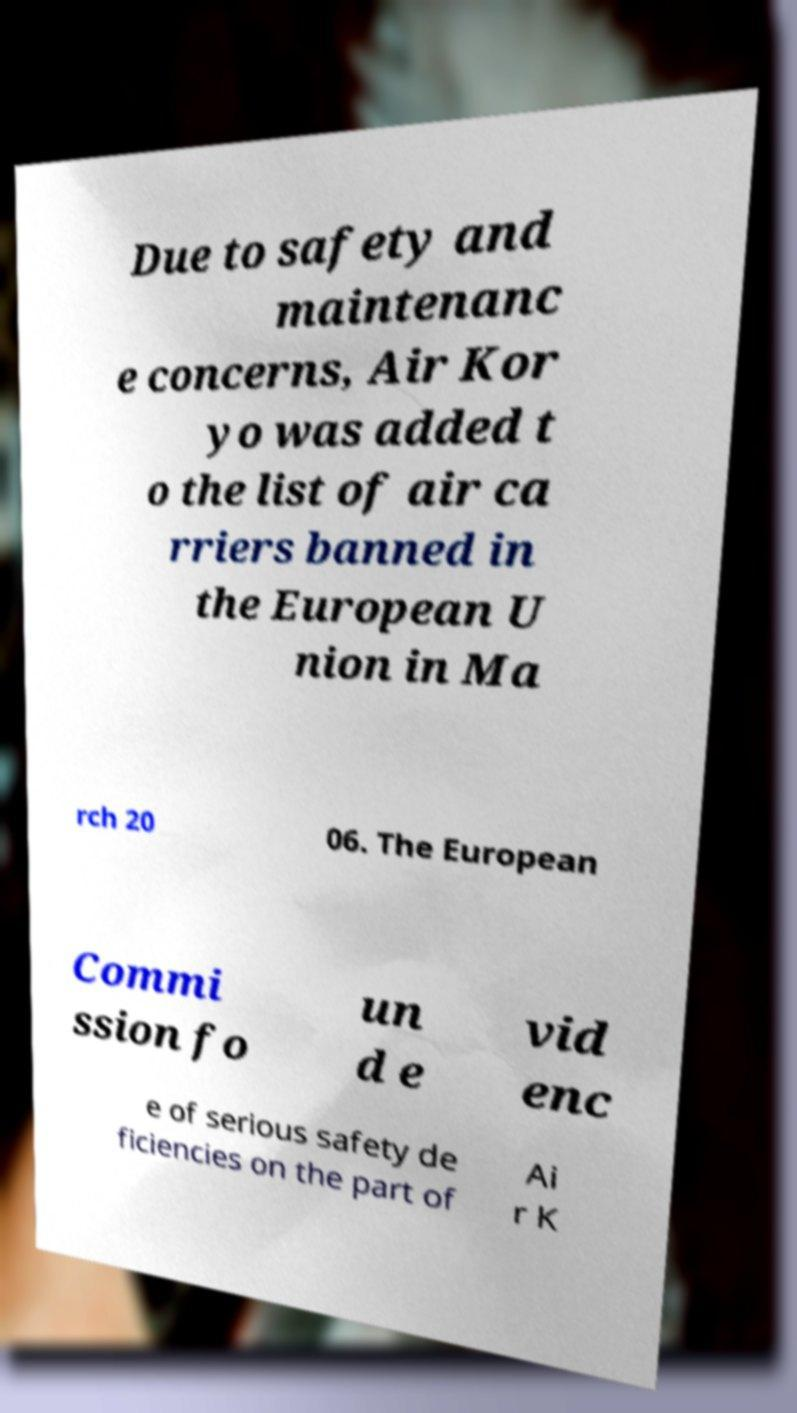For documentation purposes, I need the text within this image transcribed. Could you provide that? Due to safety and maintenanc e concerns, Air Kor yo was added t o the list of air ca rriers banned in the European U nion in Ma rch 20 06. The European Commi ssion fo un d e vid enc e of serious safety de ficiencies on the part of Ai r K 